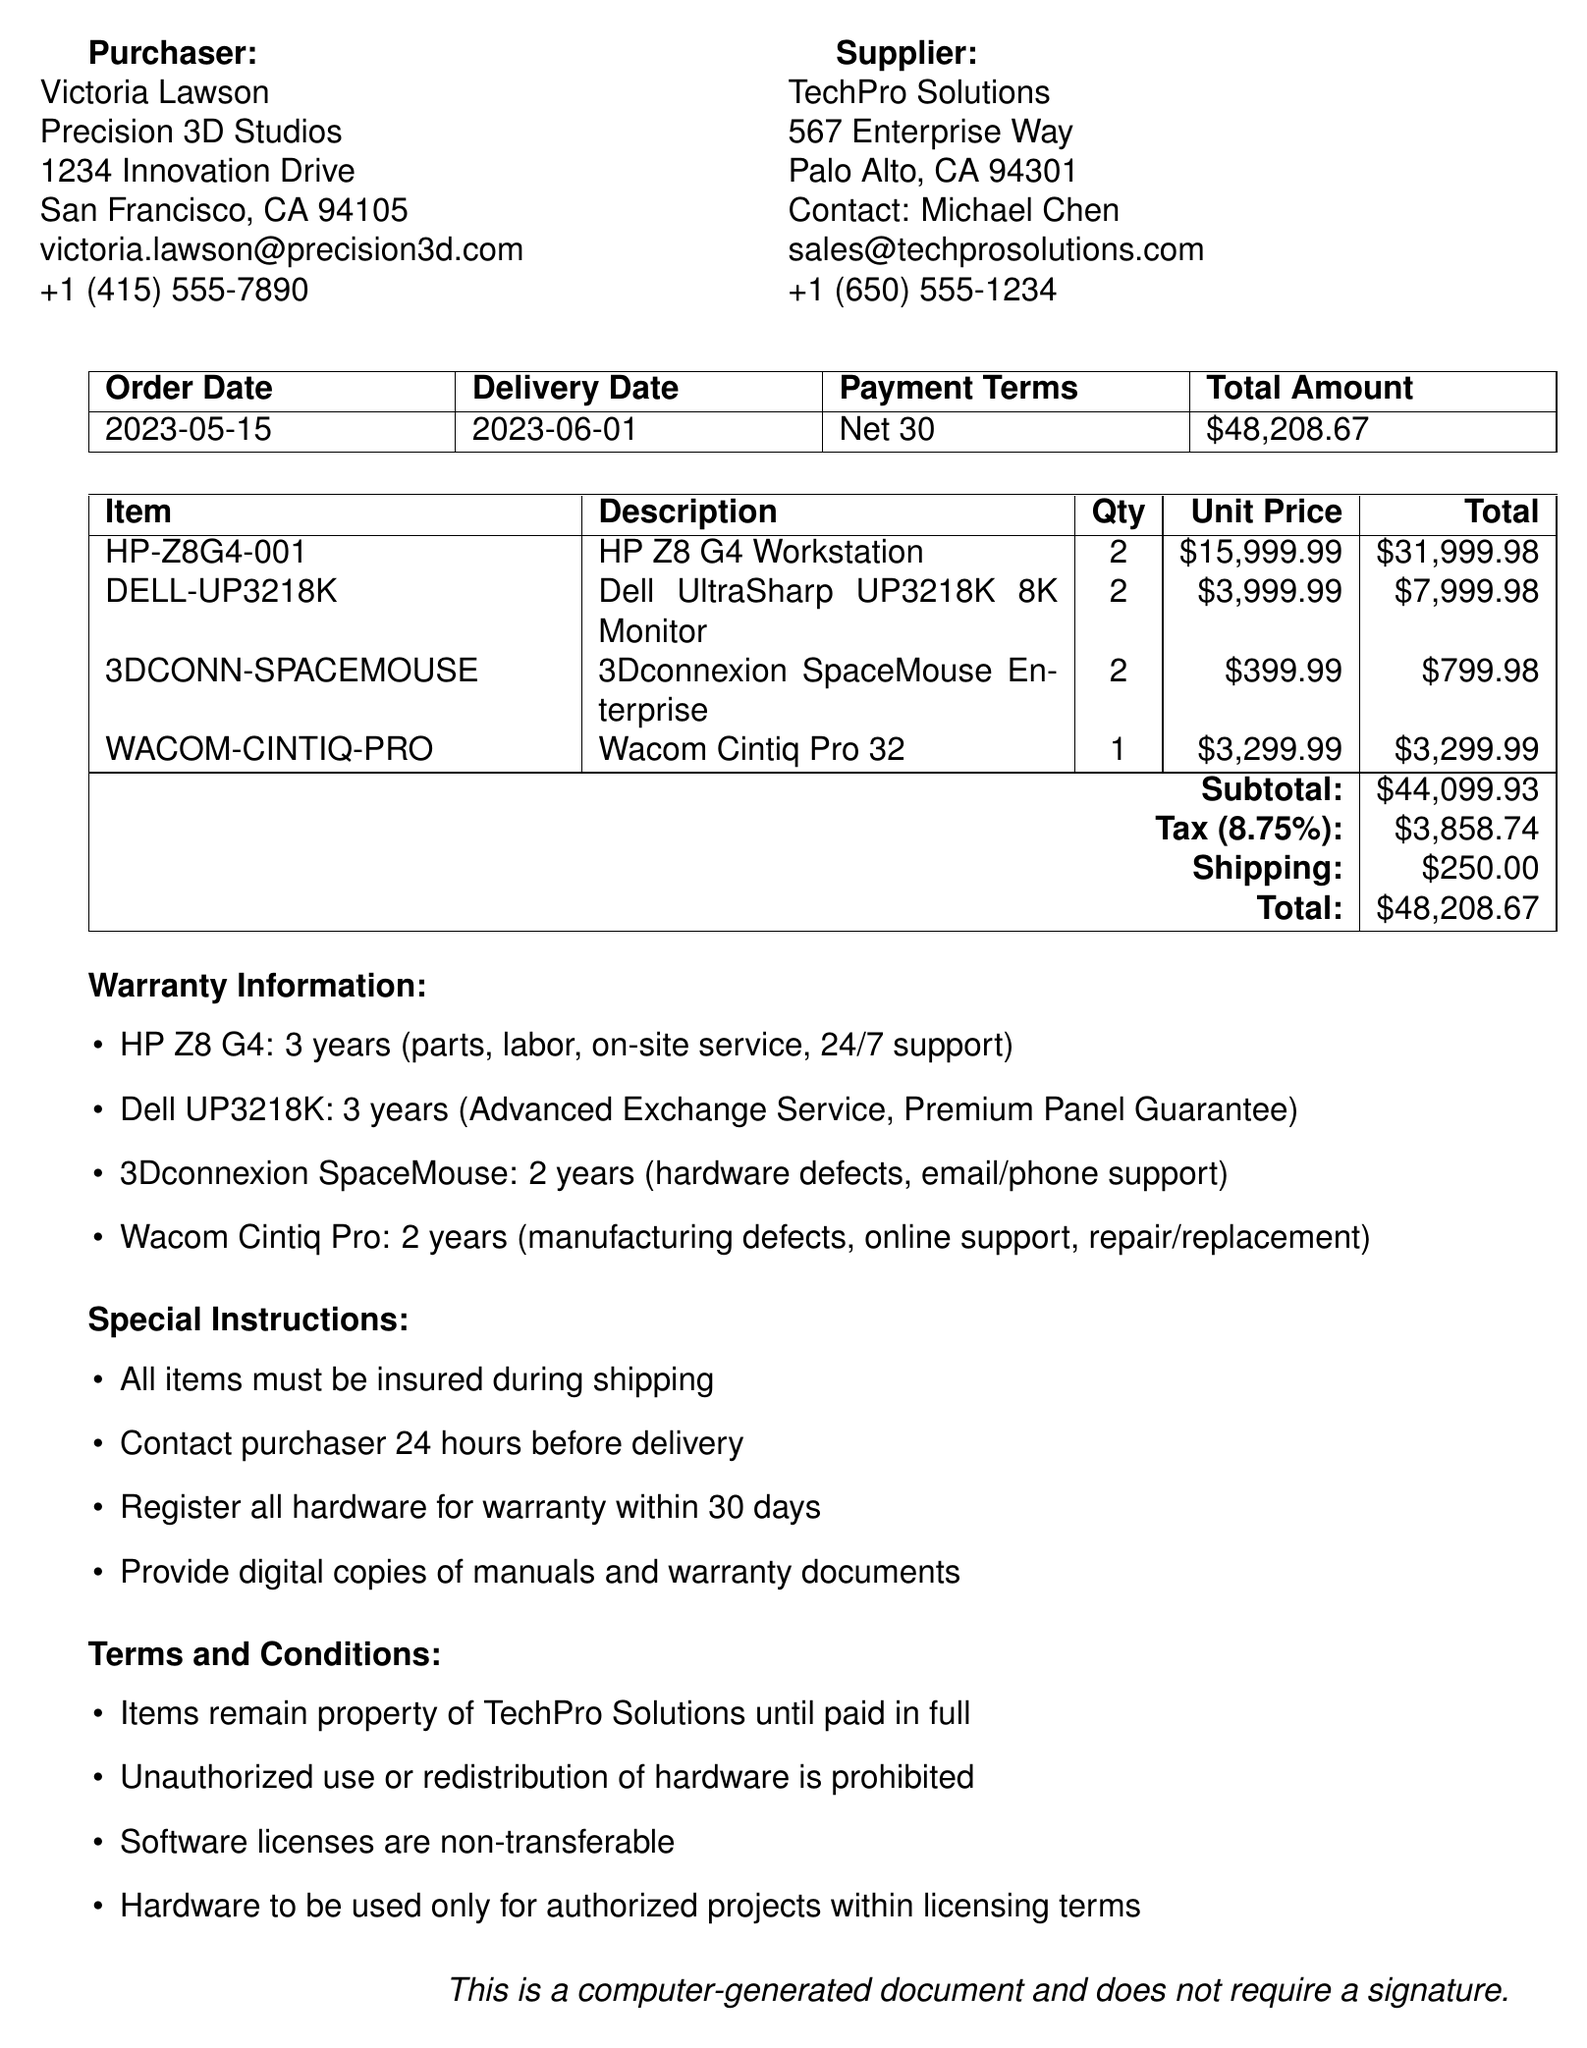What is the purchaser's name? The purchaser's name is specified at the beginning of the document.
Answer: Victoria Lawson What is the order number? The order number is a unique identifier assigned to this purchase order mentioned in the document.
Answer: PO-2023-0542 What is the total amount for the order? The total amount is calculated at the end of the order details section.
Answer: $48,208.67 How many HP Z8 G4 Workstations were ordered? The quantity of HP Z8 G4 Workstations is listed under the items section of the document.
Answer: 2 What is the warranty duration for the Wacom Cintiq Pro? The warranty information lists the duration for each item, including the Wacom Cintiq Pro.
Answer: 2 years What are the payment terms? The payment terms specify the conditions under which the payment for the order should be made.
Answer: Net 30 What special instruction requires action before delivery? One of the special instructions specifies an action that needs to be taken by the supplier prior to delivery.
Answer: Contact purchaser 24 hours before delivery What is the tax rate applied to the order? The tax rate is stated within the financial details of the order.
Answer: 8.75% What are the terms regarding unauthorized use? The terms and conditions section includes specific regulations about how the hardware can be used.
Answer: Unauthorized use or redistribution of supplied hardware is strictly prohibited 